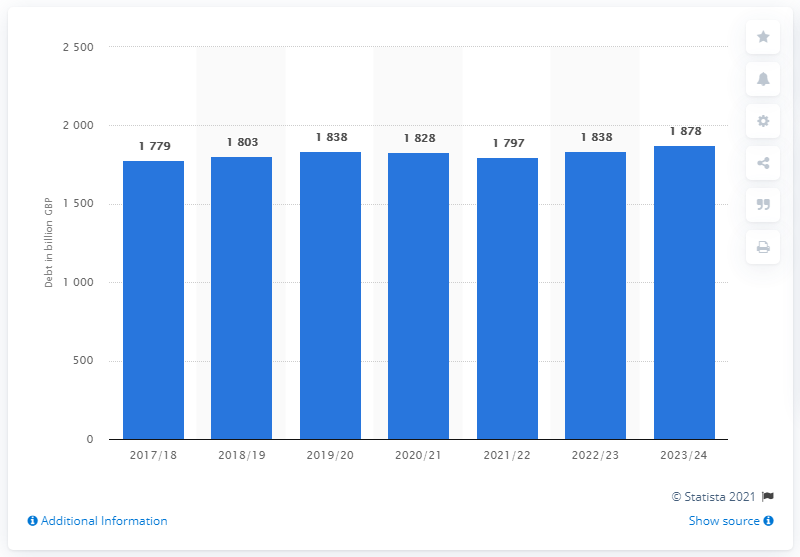Identify some key points in this picture. In the year 2017/18, the public sector net debt in the UK began to change. The peak of public sector net debt was reached in 2023/24. The statistic predicts a significant increase in public sector net debt in the UK by 2023/24. 